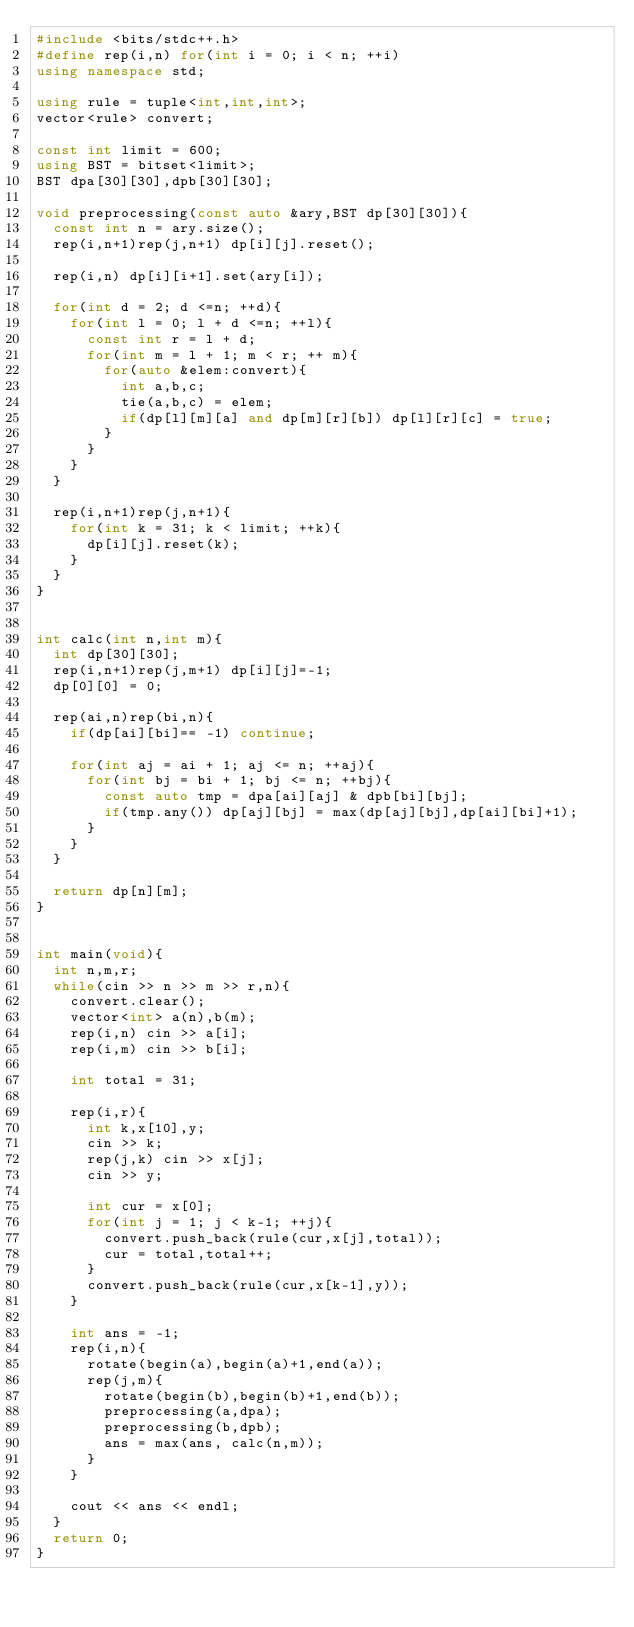Convert code to text. <code><loc_0><loc_0><loc_500><loc_500><_C++_>#include <bits/stdc++.h>
#define rep(i,n) for(int i = 0; i < n; ++i)
using namespace std;

using rule = tuple<int,int,int>;
vector<rule> convert;

const int limit = 600;
using BST = bitset<limit>;
BST dpa[30][30],dpb[30][30];

void preprocessing(const auto &ary,BST dp[30][30]){
	const int n = ary.size();
	rep(i,n+1)rep(j,n+1) dp[i][j].reset();

	rep(i,n) dp[i][i+1].set(ary[i]);

	for(int d = 2; d <=n; ++d){
		for(int l = 0; l + d <=n; ++l){
			const int r = l + d;
			for(int m = l + 1; m < r; ++ m){
				for(auto &elem:convert){
					int a,b,c;
					tie(a,b,c) = elem;
					if(dp[l][m][a] and dp[m][r][b]) dp[l][r][c] = true;
				}
			}
		}
	}

	rep(i,n+1)rep(j,n+1){
		for(int k = 31; k < limit; ++k){
			dp[i][j].reset(k);
		}
	}
}


int calc(int n,int m){
	int dp[30][30];
	rep(i,n+1)rep(j,m+1) dp[i][j]=-1;	
	dp[0][0] = 0;

	rep(ai,n)rep(bi,n){
		if(dp[ai][bi]== -1) continue;

		for(int aj = ai + 1; aj <= n; ++aj){
			for(int bj = bi + 1; bj <= n; ++bj){
				const auto tmp = dpa[ai][aj] & dpb[bi][bj];
				if(tmp.any()) dp[aj][bj] = max(dp[aj][bj],dp[ai][bi]+1);
			}
		}
	}

	return dp[n][m];
}


int main(void){
	int n,m,r;
	while(cin >> n >> m >> r,n){
		convert.clear();
		vector<int> a(n),b(m);
		rep(i,n) cin >> a[i];
		rep(i,m) cin >> b[i];

		int total = 31;

		rep(i,r){
			int k,x[10],y;
			cin >> k;
			rep(j,k) cin >> x[j];
			cin >> y;
		
			int cur = x[0];
			for(int j = 1; j < k-1; ++j){
				convert.push_back(rule(cur,x[j],total));
				cur = total,total++;
			}
			convert.push_back(rule(cur,x[k-1],y));
		}

		int ans = -1;
		rep(i,n){
			rotate(begin(a),begin(a)+1,end(a));
			rep(j,m){
				rotate(begin(b),begin(b)+1,end(b));
				preprocessing(a,dpa);
				preprocessing(b,dpb);
				ans = max(ans, calc(n,m));
			}
		}

		cout << ans << endl;
	}
	return 0;
}</code> 